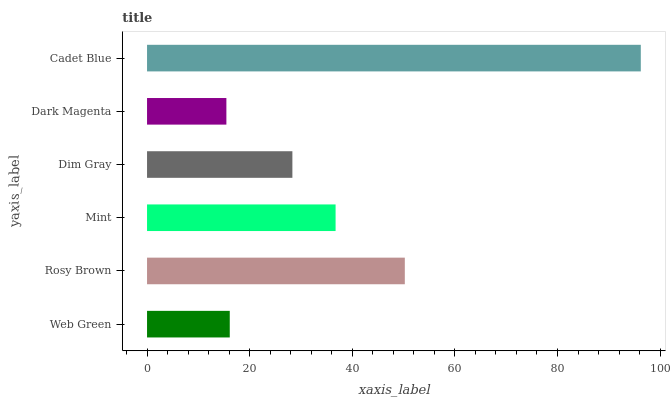Is Dark Magenta the minimum?
Answer yes or no. Yes. Is Cadet Blue the maximum?
Answer yes or no. Yes. Is Rosy Brown the minimum?
Answer yes or no. No. Is Rosy Brown the maximum?
Answer yes or no. No. Is Rosy Brown greater than Web Green?
Answer yes or no. Yes. Is Web Green less than Rosy Brown?
Answer yes or no. Yes. Is Web Green greater than Rosy Brown?
Answer yes or no. No. Is Rosy Brown less than Web Green?
Answer yes or no. No. Is Mint the high median?
Answer yes or no. Yes. Is Dim Gray the low median?
Answer yes or no. Yes. Is Rosy Brown the high median?
Answer yes or no. No. Is Cadet Blue the low median?
Answer yes or no. No. 